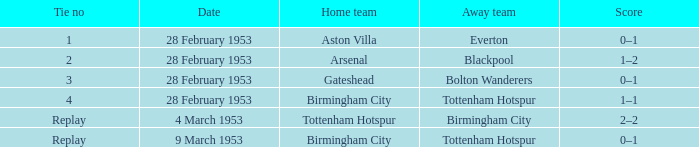Which Tie no has a Score of 0–1, and a Date of 9 march 1953? Replay. 